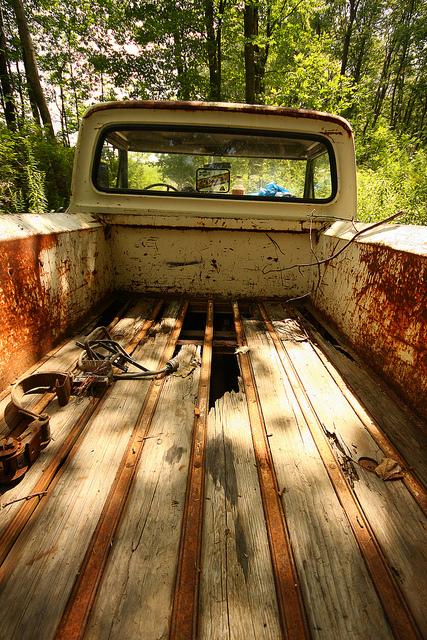Is this truck abandoned?
Write a very short answer. Yes. Is the truck bed empty?
Keep it brief. No. What color is the truck?
Write a very short answer. White. 